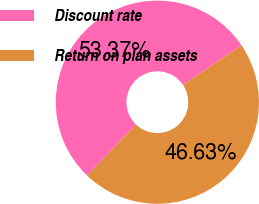Convert chart to OTSL. <chart><loc_0><loc_0><loc_500><loc_500><pie_chart><fcel>Discount rate<fcel>Return on plan assets<nl><fcel>53.37%<fcel>46.63%<nl></chart> 